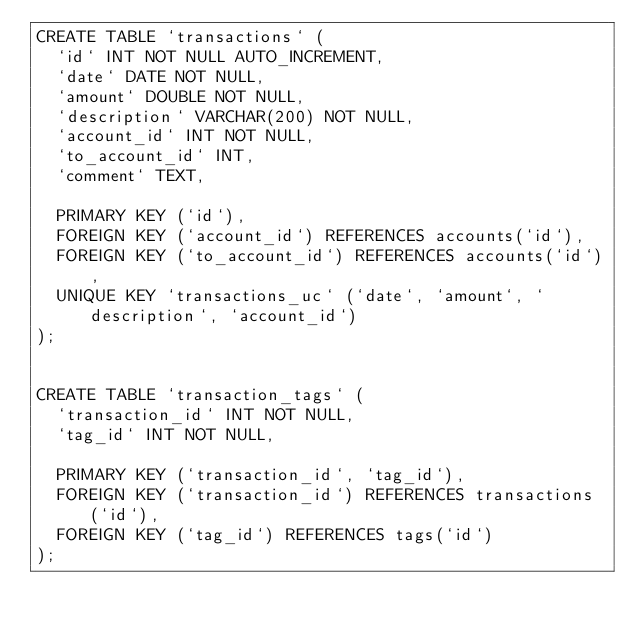Convert code to text. <code><loc_0><loc_0><loc_500><loc_500><_SQL_>CREATE TABLE `transactions` (
  `id` INT NOT NULL AUTO_INCREMENT,
  `date` DATE NOT NULL,
  `amount` DOUBLE NOT NULL,  
  `description` VARCHAR(200) NOT NULL,  
  `account_id` INT NOT NULL,
  `to_account_id` INT,
  `comment` TEXT,
  
  PRIMARY KEY (`id`),
  FOREIGN KEY (`account_id`) REFERENCES accounts(`id`),
  FOREIGN KEY (`to_account_id`) REFERENCES accounts(`id`),
  UNIQUE KEY `transactions_uc` (`date`, `amount`, `description`, `account_id`)
);


CREATE TABLE `transaction_tags` (
  `transaction_id` INT NOT NULL,
  `tag_id` INT NOT NULL,
  
  PRIMARY KEY (`transaction_id`, `tag_id`),
  FOREIGN KEY (`transaction_id`) REFERENCES transactions(`id`),
  FOREIGN KEY (`tag_id`) REFERENCES tags(`id`)
);
</code> 